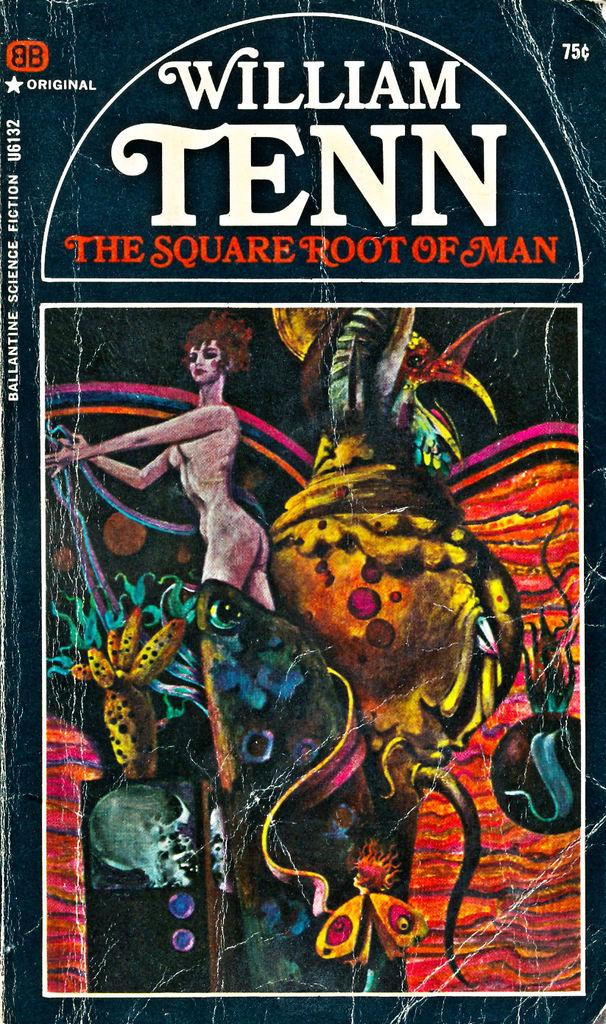What is the main subject in the center of the image? There is a poster in the center of the image. What is depicted on the poster? The poster features a woman standing. What text is written on the poster? The text "William Tenn" is written on the poster. How many spiders are crawling on the woman's face in the image? There are no spiders present in the image; the poster features a woman standing with no spiders visible. 